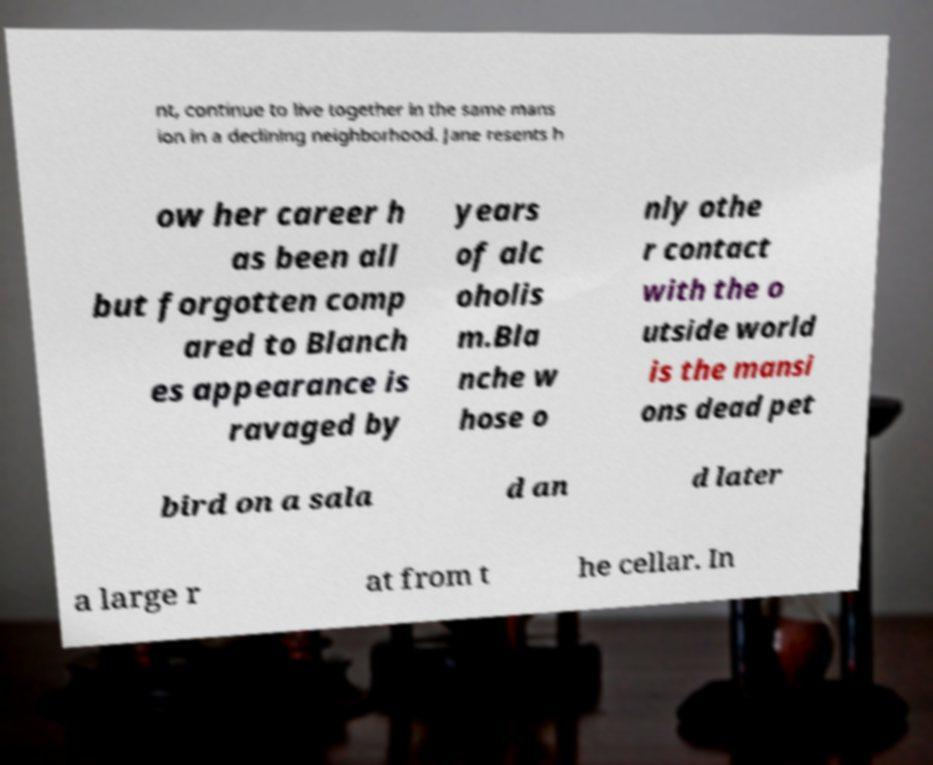Can you accurately transcribe the text from the provided image for me? nt, continue to live together in the same mans ion in a declining neighborhood. Jane resents h ow her career h as been all but forgotten comp ared to Blanch es appearance is ravaged by years of alc oholis m.Bla nche w hose o nly othe r contact with the o utside world is the mansi ons dead pet bird on a sala d an d later a large r at from t he cellar. In 